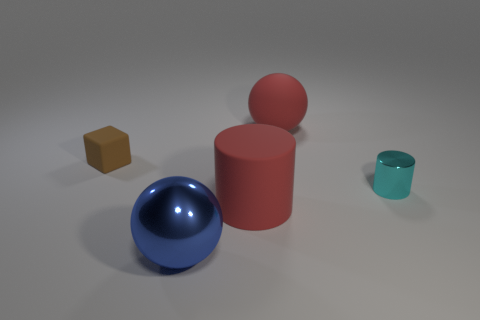How many tiny things are the same color as the block?
Your answer should be compact. 0. Are there fewer small cyan cylinders that are behind the red ball than brown blocks that are to the left of the red cylinder?
Your answer should be compact. Yes. There is a red object behind the tiny cyan metallic cylinder; is it the same shape as the blue metal object?
Keep it short and to the point. Yes. Does the tiny thing to the right of the big blue sphere have the same material as the big cylinder?
Offer a very short reply. No. What is the block in front of the big matte thing that is on the right side of the large matte thing that is in front of the small brown rubber object made of?
Your response must be concise. Rubber. What number of other things are the same shape as the tiny brown object?
Your response must be concise. 0. What color is the tiny thing to the right of the red matte ball?
Give a very brief answer. Cyan. There is a metallic thing that is on the left side of the rubber thing in front of the tiny metal cylinder; how many large red spheres are behind it?
Provide a short and direct response. 1. There is a big object in front of the matte cylinder; how many tiny objects are left of it?
Your answer should be very brief. 1. How many red things are behind the brown rubber cube?
Offer a very short reply. 1. 